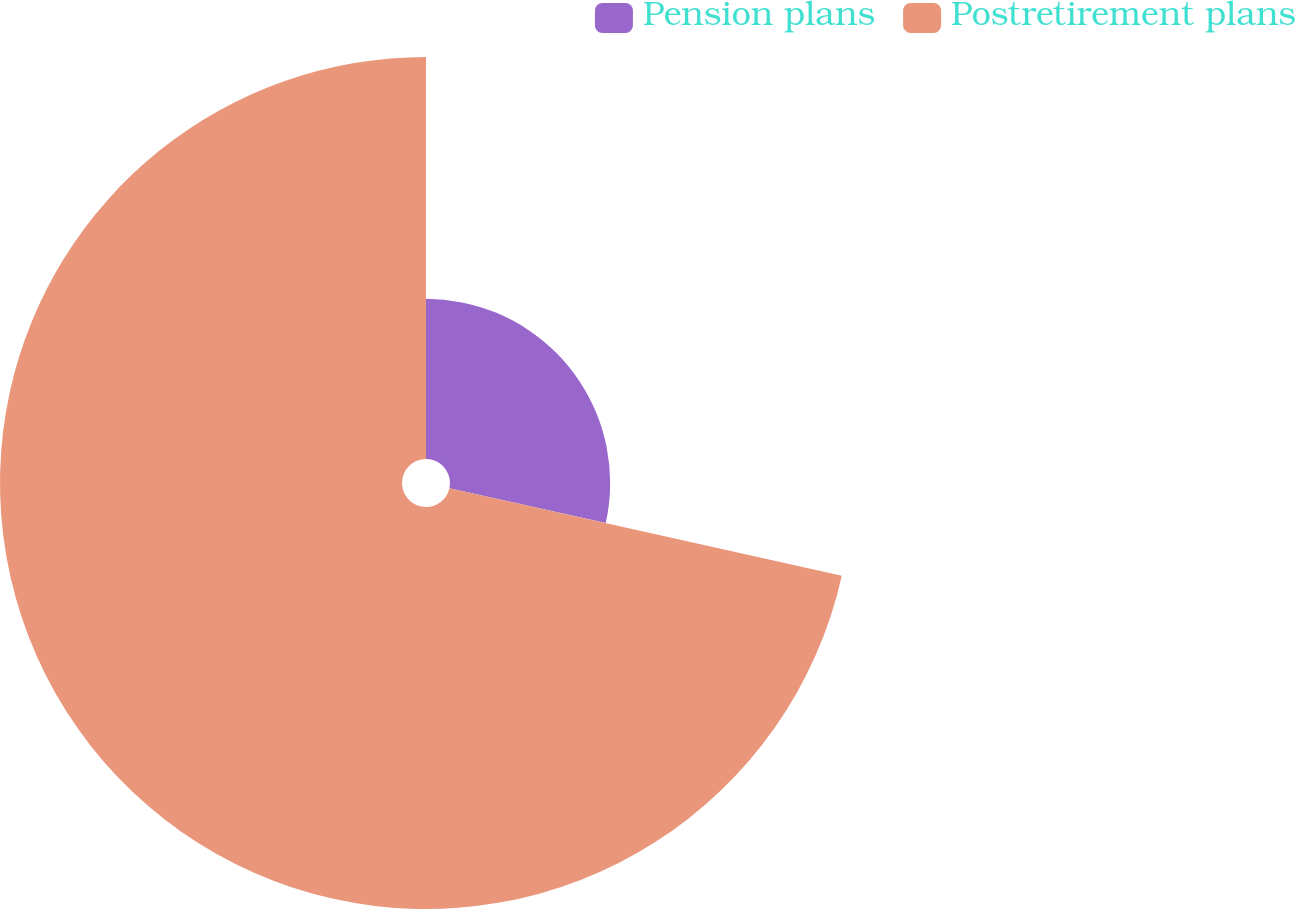<chart> <loc_0><loc_0><loc_500><loc_500><pie_chart><fcel>Pension plans<fcel>Postretirement plans<nl><fcel>28.49%<fcel>71.51%<nl></chart> 